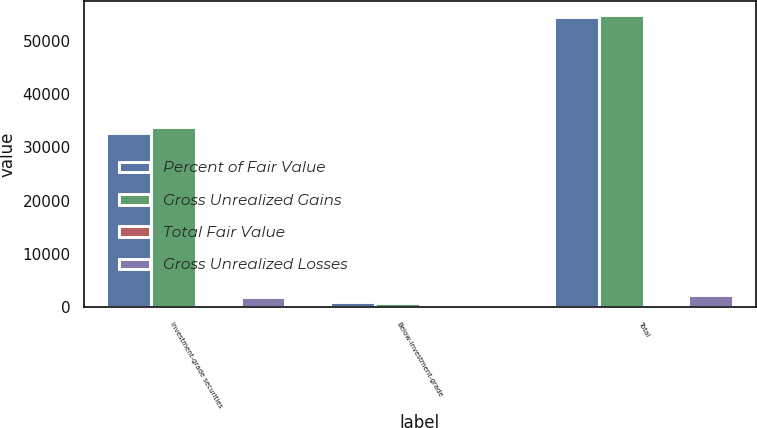Convert chart. <chart><loc_0><loc_0><loc_500><loc_500><stacked_bar_chart><ecel><fcel>Investment-grade securities<fcel>Below-investment-grade<fcel>Total<nl><fcel>Percent of Fair Value<fcel>32639<fcel>1032<fcel>54475<nl><fcel>Gross Unrealized Gains<fcel>33791<fcel>815<fcel>54731<nl><fcel>Total Fair Value<fcel>61.7<fcel>1.5<fcel>100<nl><fcel>Gross Unrealized Losses<fcel>1968<fcel>2<fcel>2378<nl></chart> 